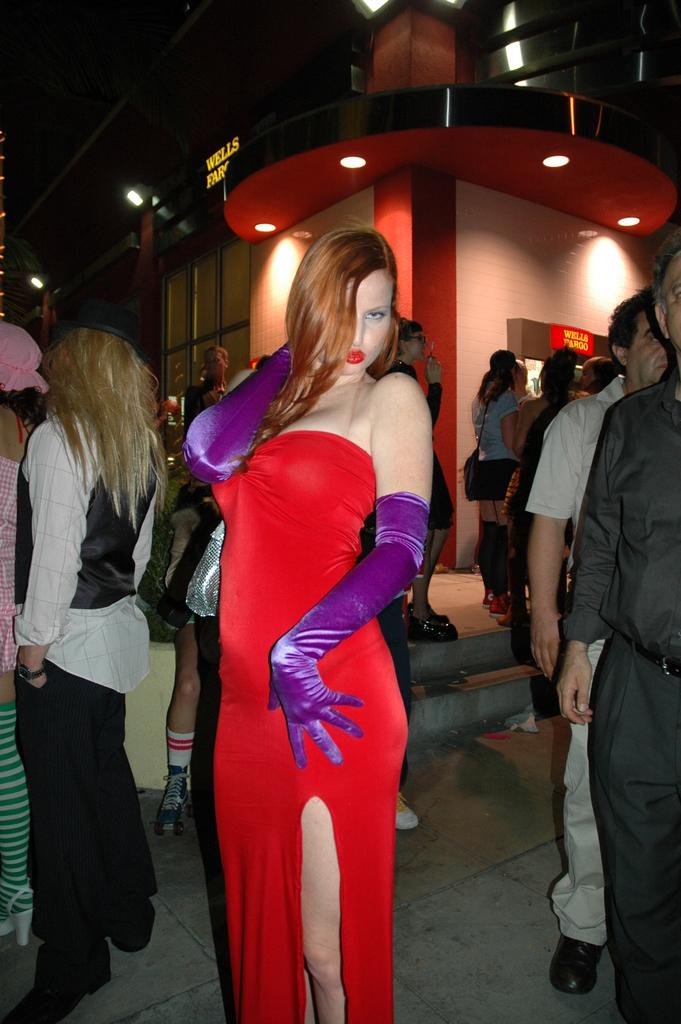How many people are in the image? There is a group of people present in the image. What else can be seen in the image besides the people? There are buildings and lights visible in the image. Can you describe the woman standing in the front of the group? The woman standing in the front of the group is wearing a red color dress. How would you describe the lighting in the image? The image is a little dark. Where is the baby located in the image? There is no baby present in the image. What type of mailbox can be seen near the buildings in the image? There is no mailbox visible in the image. 